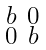<formula> <loc_0><loc_0><loc_500><loc_500>\begin{smallmatrix} b & 0 \\ 0 & b \end{smallmatrix}</formula> 